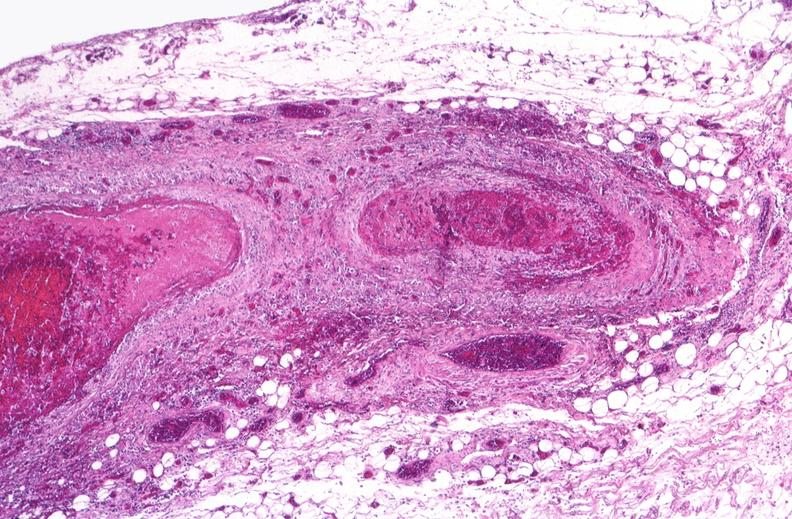does this image show polyarteritis nodosa?
Answer the question using a single word or phrase. Yes 